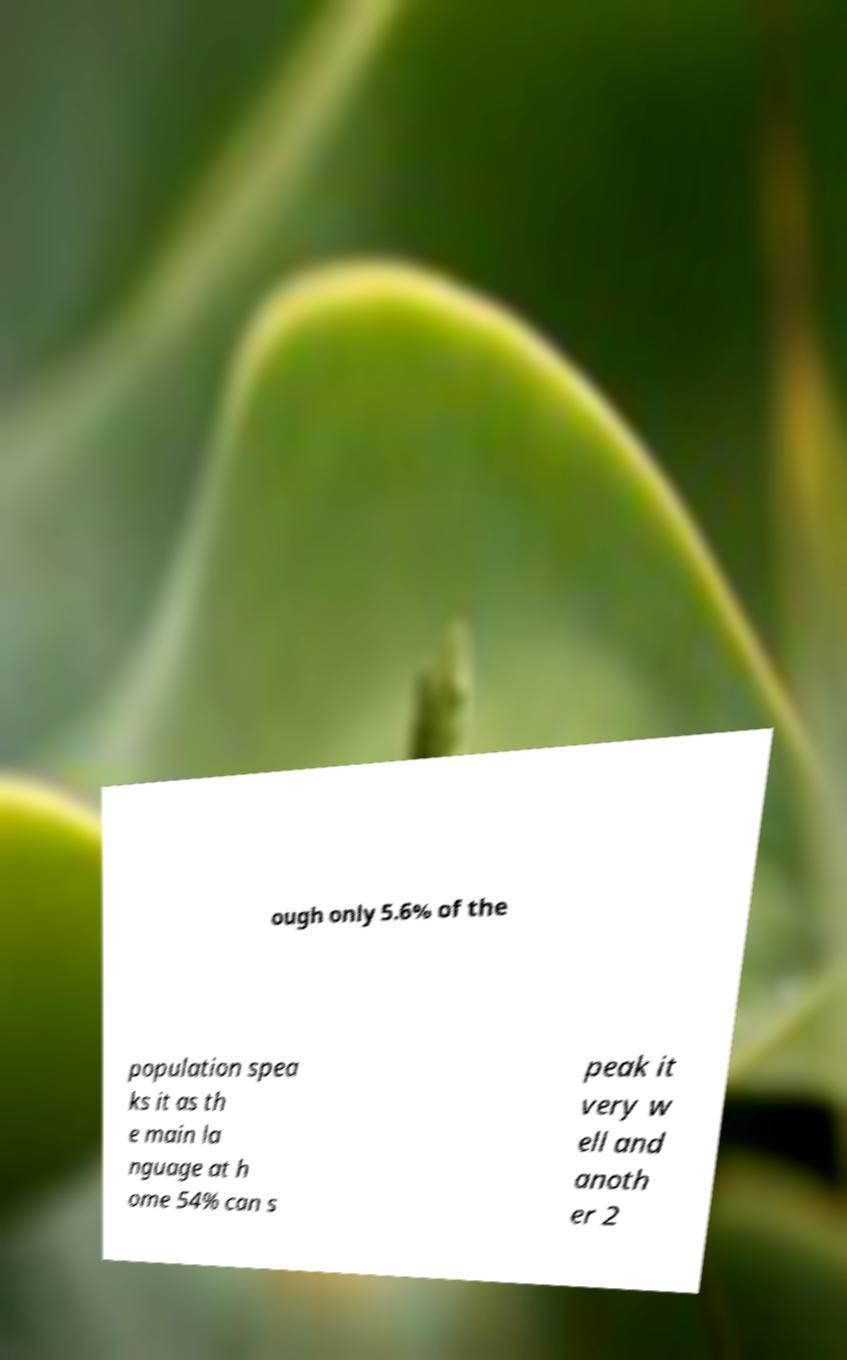I need the written content from this picture converted into text. Can you do that? ough only 5.6% of the population spea ks it as th e main la nguage at h ome 54% can s peak it very w ell and anoth er 2 